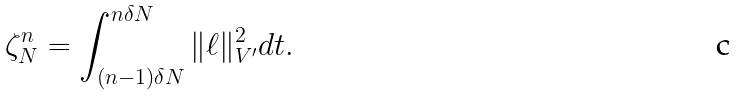<formula> <loc_0><loc_0><loc_500><loc_500>\zeta ^ { n } _ { N } = \int _ { ( n - 1 ) \delta N } ^ { n \delta N } \| \ell \| _ { V ^ { \prime } } ^ { 2 } d t .</formula> 